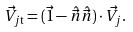<formula> <loc_0><loc_0><loc_500><loc_500>\vec { V } _ { j \mathrm t } = ( \vec { 1 } - \hat { \vec { n } } \hat { \vec { n } } ) \cdot { \vec { V } } _ { j } .</formula> 